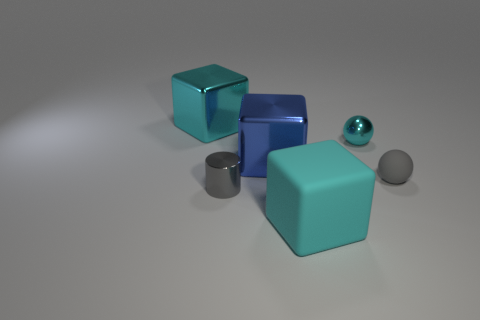How does the arrangement of the objects impact the aesthetics of the image? The composition of the objects is visually balanced, with the largest cube slightly off-center and the smaller objects surrounding it. The placement of the spherical objects, one large and one small, creates a contrast in size that adds interest. The spacing between objects is even, which provides a clean and orderly aesthetic. Overall, the arrangement creates a sense of harmony and deliberate design. 